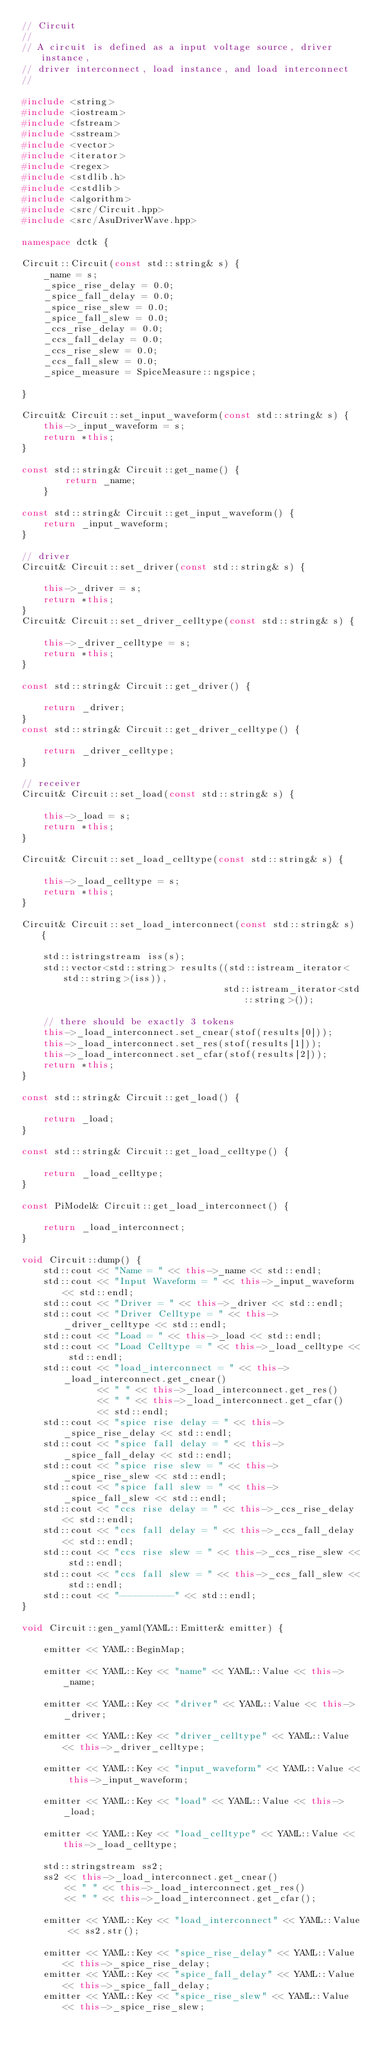<code> <loc_0><loc_0><loc_500><loc_500><_C++_>// Circuit
//
// A circuit is defined as a input voltage source, driver instance,
// driver interconnect, load instance, and load interconnect
//

#include <string>
#include <iostream>
#include <fstream>
#include <sstream>
#include <vector>
#include <iterator>
#include <regex>
#include <stdlib.h>
#include <cstdlib>
#include <algorithm>
#include <src/Circuit.hpp>
#include <src/AsuDriverWave.hpp>

namespace dctk {

Circuit::Circuit(const std::string& s) {
    _name = s;
    _spice_rise_delay = 0.0;
    _spice_fall_delay = 0.0;
    _spice_rise_slew = 0.0;
    _spice_fall_slew = 0.0;
    _ccs_rise_delay = 0.0;
    _ccs_fall_delay = 0.0;
    _ccs_rise_slew = 0.0;
    _ccs_fall_slew = 0.0;
    _spice_measure = SpiceMeasure::ngspice;
    
}

Circuit& Circuit::set_input_waveform(const std::string& s) {
    this->_input_waveform = s;
    return *this;
}

const std::string& Circuit::get_name() {
        return _name;
    }

const std::string& Circuit::get_input_waveform() {
    return _input_waveform;
}

// driver
Circuit& Circuit::set_driver(const std::string& s) {

    this->_driver = s;
    return *this;
}
Circuit& Circuit::set_driver_celltype(const std::string& s) {

    this->_driver_celltype = s;
    return *this;
}

const std::string& Circuit::get_driver() {

    return _driver;
}
const std::string& Circuit::get_driver_celltype() {

    return _driver_celltype;
}

// receiver
Circuit& Circuit::set_load(const std::string& s) {

    this->_load = s;
    return *this;
}

Circuit& Circuit::set_load_celltype(const std::string& s) {

    this->_load_celltype = s;
    return *this;
}

Circuit& Circuit::set_load_interconnect(const std::string& s) {

    std::istringstream iss(s);
    std::vector<std::string> results((std::istream_iterator<std::string>(iss)),
                                     std::istream_iterator<std::string>());

    // there should be exactly 3 tokens
    this->_load_interconnect.set_cnear(stof(results[0]));
    this->_load_interconnect.set_res(stof(results[1]));
    this->_load_interconnect.set_cfar(stof(results[2]));
    return *this;
}

const std::string& Circuit::get_load() {

    return _load;
}

const std::string& Circuit::get_load_celltype() {

    return _load_celltype;
}

const PiModel& Circuit::get_load_interconnect() {

    return _load_interconnect;
}

void Circuit::dump() {
    std::cout << "Name = " << this->_name << std::endl;
    std::cout << "Input Waveform = " << this->_input_waveform << std::endl;
    std::cout << "Driver = " << this->_driver << std::endl;
    std::cout << "Driver Celltype = " << this->_driver_celltype << std::endl;
    std::cout << "Load = " << this->_load << std::endl;
    std::cout << "Load Celltype = " << this->_load_celltype << std::endl;
    std::cout << "load_interconnect = " << this->_load_interconnect.get_cnear()
              << " " << this->_load_interconnect.get_res()
              << " " << this->_load_interconnect.get_cfar()
              << std::endl;
    std::cout << "spice rise delay = " << this->_spice_rise_delay << std::endl;
    std::cout << "spice fall delay = " << this->_spice_fall_delay << std::endl;
    std::cout << "spice rise slew = " << this->_spice_rise_slew << std::endl;
    std::cout << "spice fall slew = " << this->_spice_fall_slew << std::endl;
    std::cout << "ccs rise delay = " << this->_ccs_rise_delay << std::endl;
    std::cout << "ccs fall delay = " << this->_ccs_fall_delay << std::endl;
    std::cout << "ccs rise slew = " << this->_ccs_rise_slew << std::endl;
    std::cout << "ccs fall slew = " << this->_ccs_fall_slew << std::endl;
    std::cout << "----------" << std::endl;
}

void Circuit::gen_yaml(YAML::Emitter& emitter) {

    emitter << YAML::BeginMap;

    emitter << YAML::Key << "name" << YAML::Value << this->_name;

    emitter << YAML::Key << "driver" << YAML::Value << this->_driver;

    emitter << YAML::Key << "driver_celltype" << YAML::Value << this->_driver_celltype;

    emitter << YAML::Key << "input_waveform" << YAML::Value << this->_input_waveform;

    emitter << YAML::Key << "load" << YAML::Value << this->_load;

    emitter << YAML::Key << "load_celltype" << YAML::Value << this->_load_celltype;

    std::stringstream ss2;
    ss2 << this->_load_interconnect.get_cnear()
        << " " << this->_load_interconnect.get_res()
        << " " << this->_load_interconnect.get_cfar();

    emitter << YAML::Key << "load_interconnect" << YAML::Value << ss2.str();

    emitter << YAML::Key << "spice_rise_delay" << YAML::Value << this->_spice_rise_delay;
    emitter << YAML::Key << "spice_fall_delay" << YAML::Value << this->_spice_fall_delay;
    emitter << YAML::Key << "spice_rise_slew" << YAML::Value << this->_spice_rise_slew;</code> 